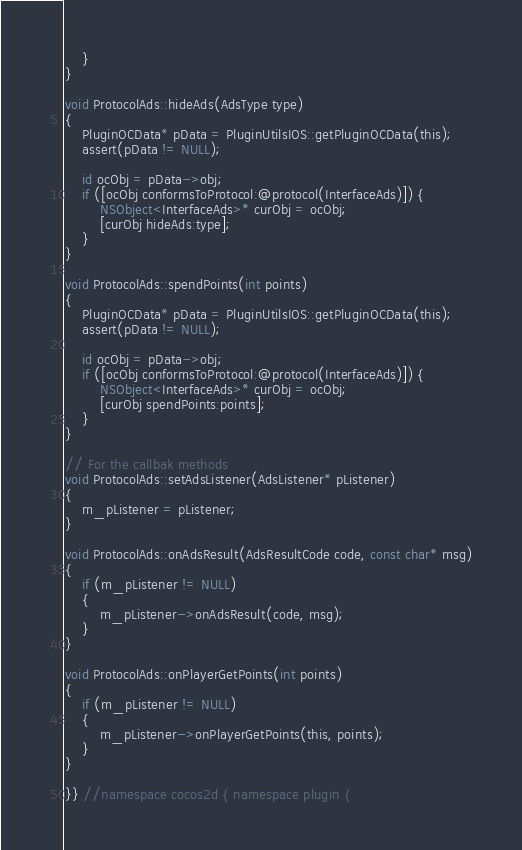<code> <loc_0><loc_0><loc_500><loc_500><_ObjectiveC_>    }
}

void ProtocolAds::hideAds(AdsType type)
{
    PluginOCData* pData = PluginUtilsIOS::getPluginOCData(this);
    assert(pData != NULL);
    
    id ocObj = pData->obj;
    if ([ocObj conformsToProtocol:@protocol(InterfaceAds)]) {
        NSObject<InterfaceAds>* curObj = ocObj;
        [curObj hideAds:type];
    }
}

void ProtocolAds::spendPoints(int points)
{
    PluginOCData* pData = PluginUtilsIOS::getPluginOCData(this);
    assert(pData != NULL);
    
    id ocObj = pData->obj;
    if ([ocObj conformsToProtocol:@protocol(InterfaceAds)]) {
        NSObject<InterfaceAds>* curObj = ocObj;
        [curObj spendPoints:points];
    }
}

// For the callbak methods
void ProtocolAds::setAdsListener(AdsListener* pListener)
{
    m_pListener = pListener;
}

void ProtocolAds::onAdsResult(AdsResultCode code, const char* msg)
{
    if (m_pListener != NULL)
    {
        m_pListener->onAdsResult(code, msg);
    }
}

void ProtocolAds::onPlayerGetPoints(int points)
{
    if (m_pListener != NULL)
    {
        m_pListener->onPlayerGetPoints(this, points);
    }
}

}} //namespace cocos2d { namespace plugin {
</code> 